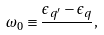<formula> <loc_0><loc_0><loc_500><loc_500>\omega _ { 0 } \equiv \frac { \epsilon _ { q ^ { \prime } } - \epsilon _ { q } } { } ,</formula> 